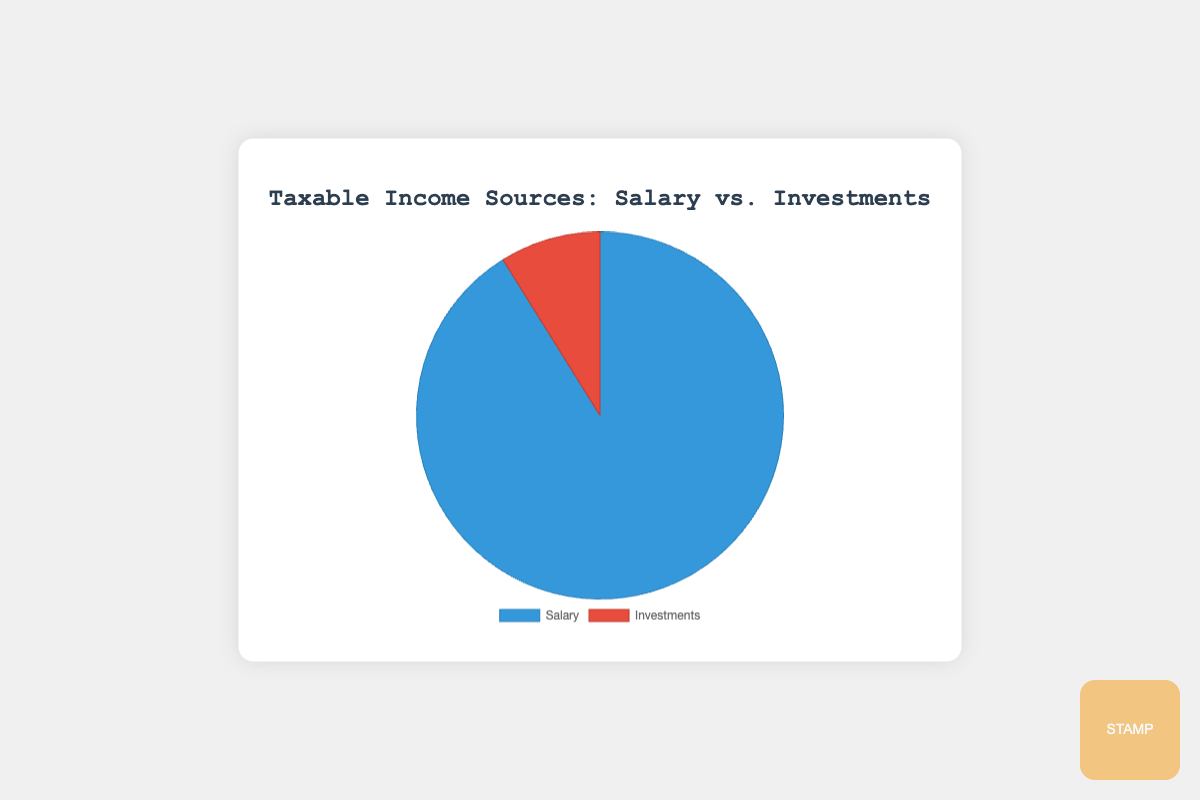What is the total income from Salary compared to Investments? The total income from Salary is calculated by summing up the amounts from Anderson Tax Consultancy, Smith & Co Accountants, and Global Tax Advisors: 75000 + 60000 + 50000 = 185000. The total income from Investments is calculated by summing up the amounts from Apple Inc. (Dividends), U.S. Treasury Bonds (Interest), and Real Estate (Capital Gains): 5000 + 3000 + 10000 = 18000. Comparing these, Salary income is 185000, and Investments income is 18000
Answer: Salary: 185000, Investments: 18000 Which income source accounts for the majority of the total income? There are two income sources: Salary and Investments. By comparing their totals, Salary income is 185000, Investments income is 18000. The majority is the one with the higher value.
Answer: Salary What percentage of the total income comes from Investments? Total income is the sum of Salary and Investments: 185000 + 18000 = 203000. The percentage of income from Investments is (18000 / 203000) * 100%, which is approximately 8.87%
Answer: 8.87% How do the incomes from Anderson Tax Consultancy and U.S. Treasury Bonds compare? The income from Anderson Tax Consultancy is 75000, and from U.S. Treasury Bonds is 3000. Anderson Tax Consultancy provides a significantly larger income.
Answer: Anderson Tax Consultancy is greater What fraction of total Salary income comes from Smith & Co Accountants? Total Salary income is 185000. Income from Smith & Co Accountants is 60000. The fraction is 60000 / 185000, which simplifies to approximately 0.3243
Answer: Approx. 0.3243 How much more is earned from Global Tax Advisors compared to all Investment sources combined? The income from Global Tax Advisors is 50000, and the total income from Investments is 18000. The difference is 50000 - 18000 = 32000
Answer: 32000 What is the average income from the three Salary sources? The incomes from the three Salary sources are 75000, 60000, and 50000. The average is calculated by (75000 + 60000 + 50000) / 3, which equals 185000 / 3 = 61666.67
Answer: 61666.67 What color represents Investments on the pie chart? The pie chart uses two colors: one for Salary and one for Investments. Based on the provided styles, Investments is represented by a red color.
Answer: Red 